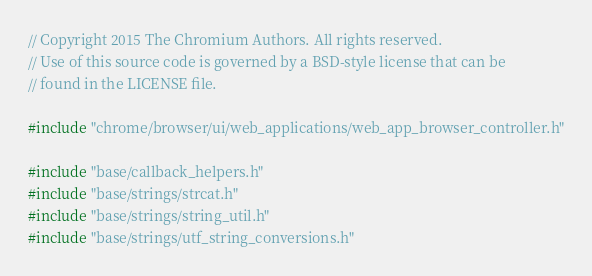Convert code to text. <code><loc_0><loc_0><loc_500><loc_500><_C++_>// Copyright 2015 The Chromium Authors. All rights reserved.
// Use of this source code is governed by a BSD-style license that can be
// found in the LICENSE file.

#include "chrome/browser/ui/web_applications/web_app_browser_controller.h"

#include "base/callback_helpers.h"
#include "base/strings/strcat.h"
#include "base/strings/string_util.h"
#include "base/strings/utf_string_conversions.h"</code> 